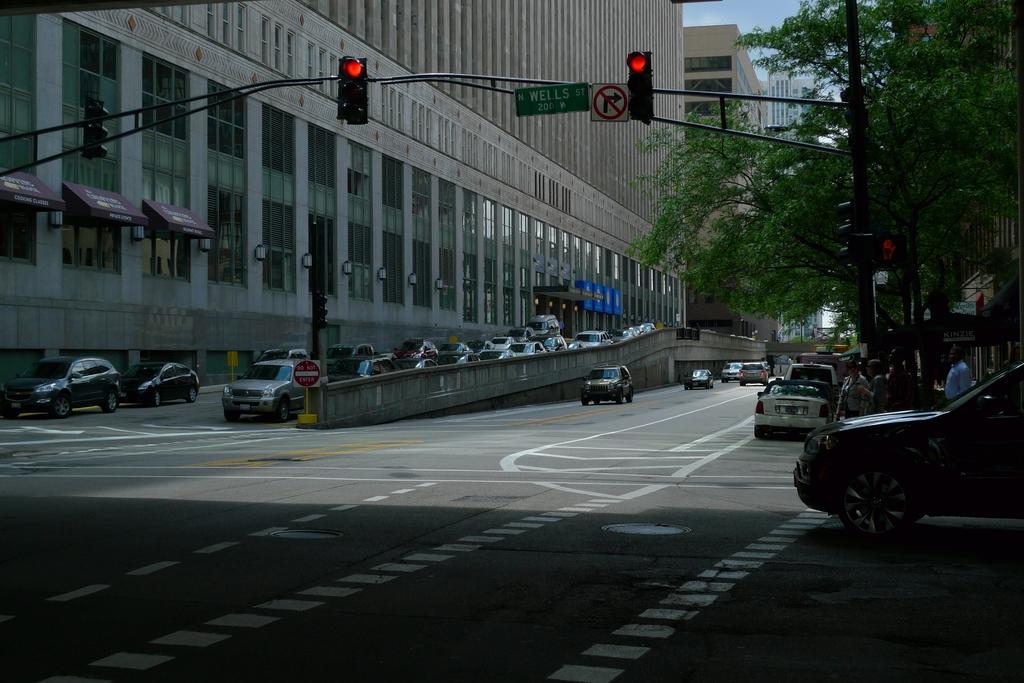Is this north or south well st?
Your answer should be very brief. North. 